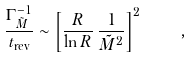Convert formula to latex. <formula><loc_0><loc_0><loc_500><loc_500>\frac { \Gamma _ { \tilde { M } } ^ { - 1 } } { t _ { \text {rev} } } \sim \left [ \frac { R } { \ln R } \, \frac { 1 } { \tilde { M } ^ { 2 } } \right ] ^ { 2 } \quad ,</formula> 